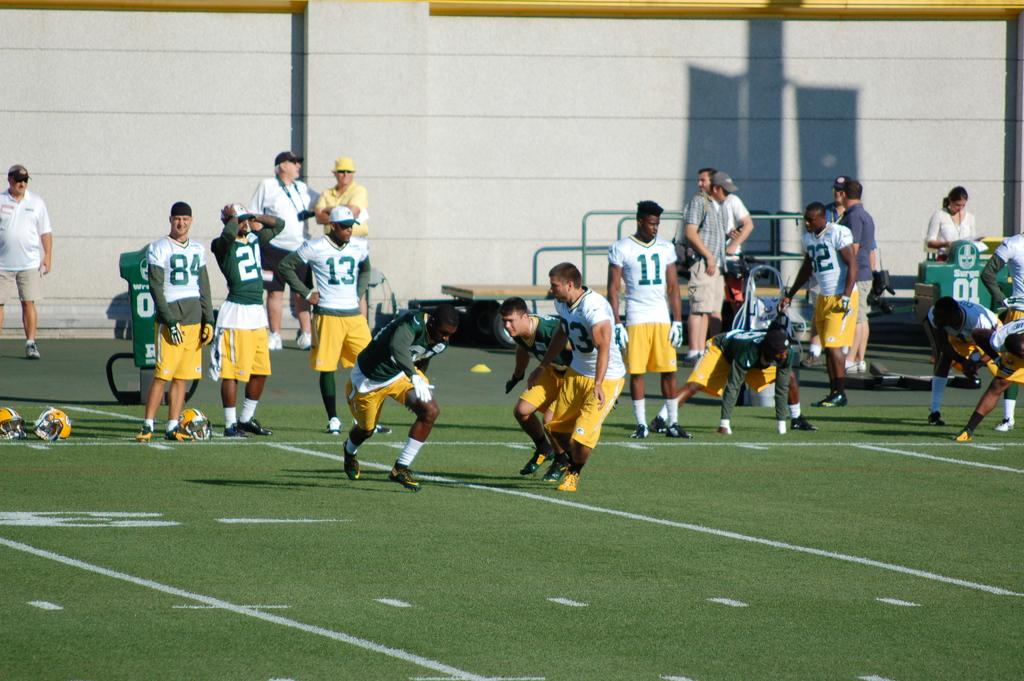<image>
Describe the image concisely. A soccer game between two teams with jerseys that say13. 